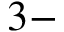<formula> <loc_0><loc_0><loc_500><loc_500>3 -</formula> 